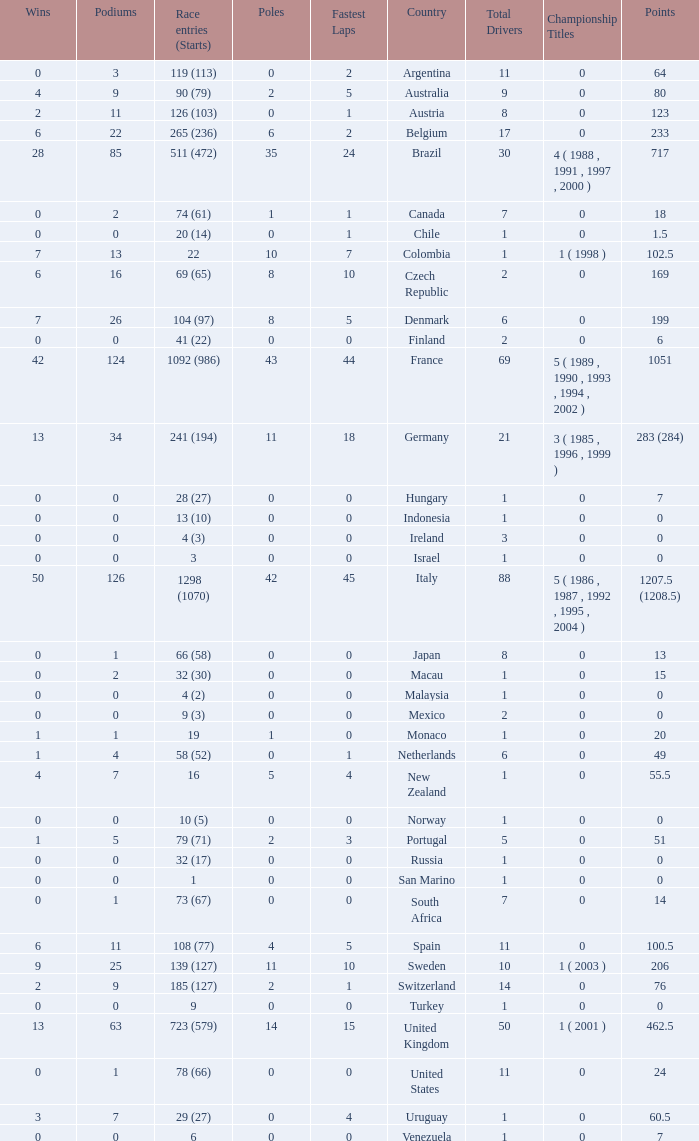How many fastest laps for the nation with 32 (30) entries and starts and fewer than 2 podiums? None. 